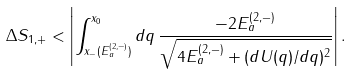<formula> <loc_0><loc_0><loc_500><loc_500>\Delta S _ { 1 , + } < \left | \int _ { x _ { - } ( E _ { a } ^ { ( 2 , - ) } ) } ^ { x _ { 0 } } d q \, \frac { - 2 E _ { a } ^ { ( 2 , - ) } } { \sqrt { 4 E _ { a } ^ { ( 2 , - ) } + ( d U ( q ) / d q ) ^ { 2 } } } \right | .</formula> 